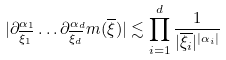<formula> <loc_0><loc_0><loc_500><loc_500>| \partial ^ { \alpha _ { 1 } } _ { \overline { \xi _ { 1 } } } \dots \partial ^ { \alpha _ { d } } _ { \overline { \xi _ { d } } } m ( \overline { \xi } ) | \lesssim \prod _ { i = 1 } ^ { d } \frac { 1 } { | \overline { \xi _ { i } } | ^ { | \alpha _ { i } | } }</formula> 